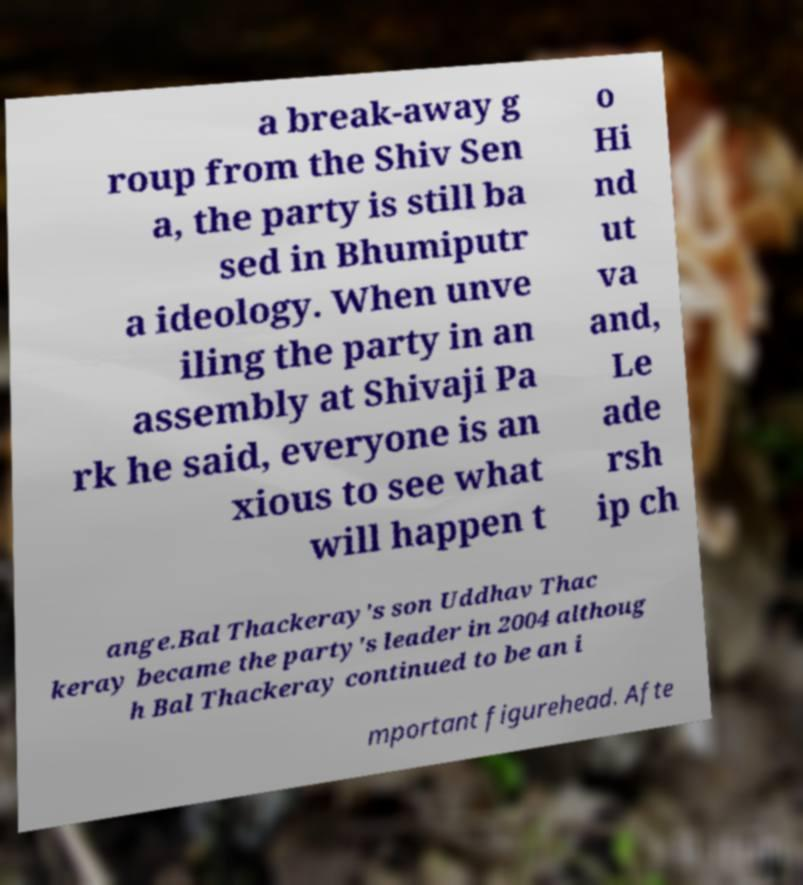Please identify and transcribe the text found in this image. a break-away g roup from the Shiv Sen a, the party is still ba sed in Bhumiputr a ideology. When unve iling the party in an assembly at Shivaji Pa rk he said, everyone is an xious to see what will happen t o Hi nd ut va and, Le ade rsh ip ch ange.Bal Thackeray's son Uddhav Thac keray became the party's leader in 2004 althoug h Bal Thackeray continued to be an i mportant figurehead. Afte 